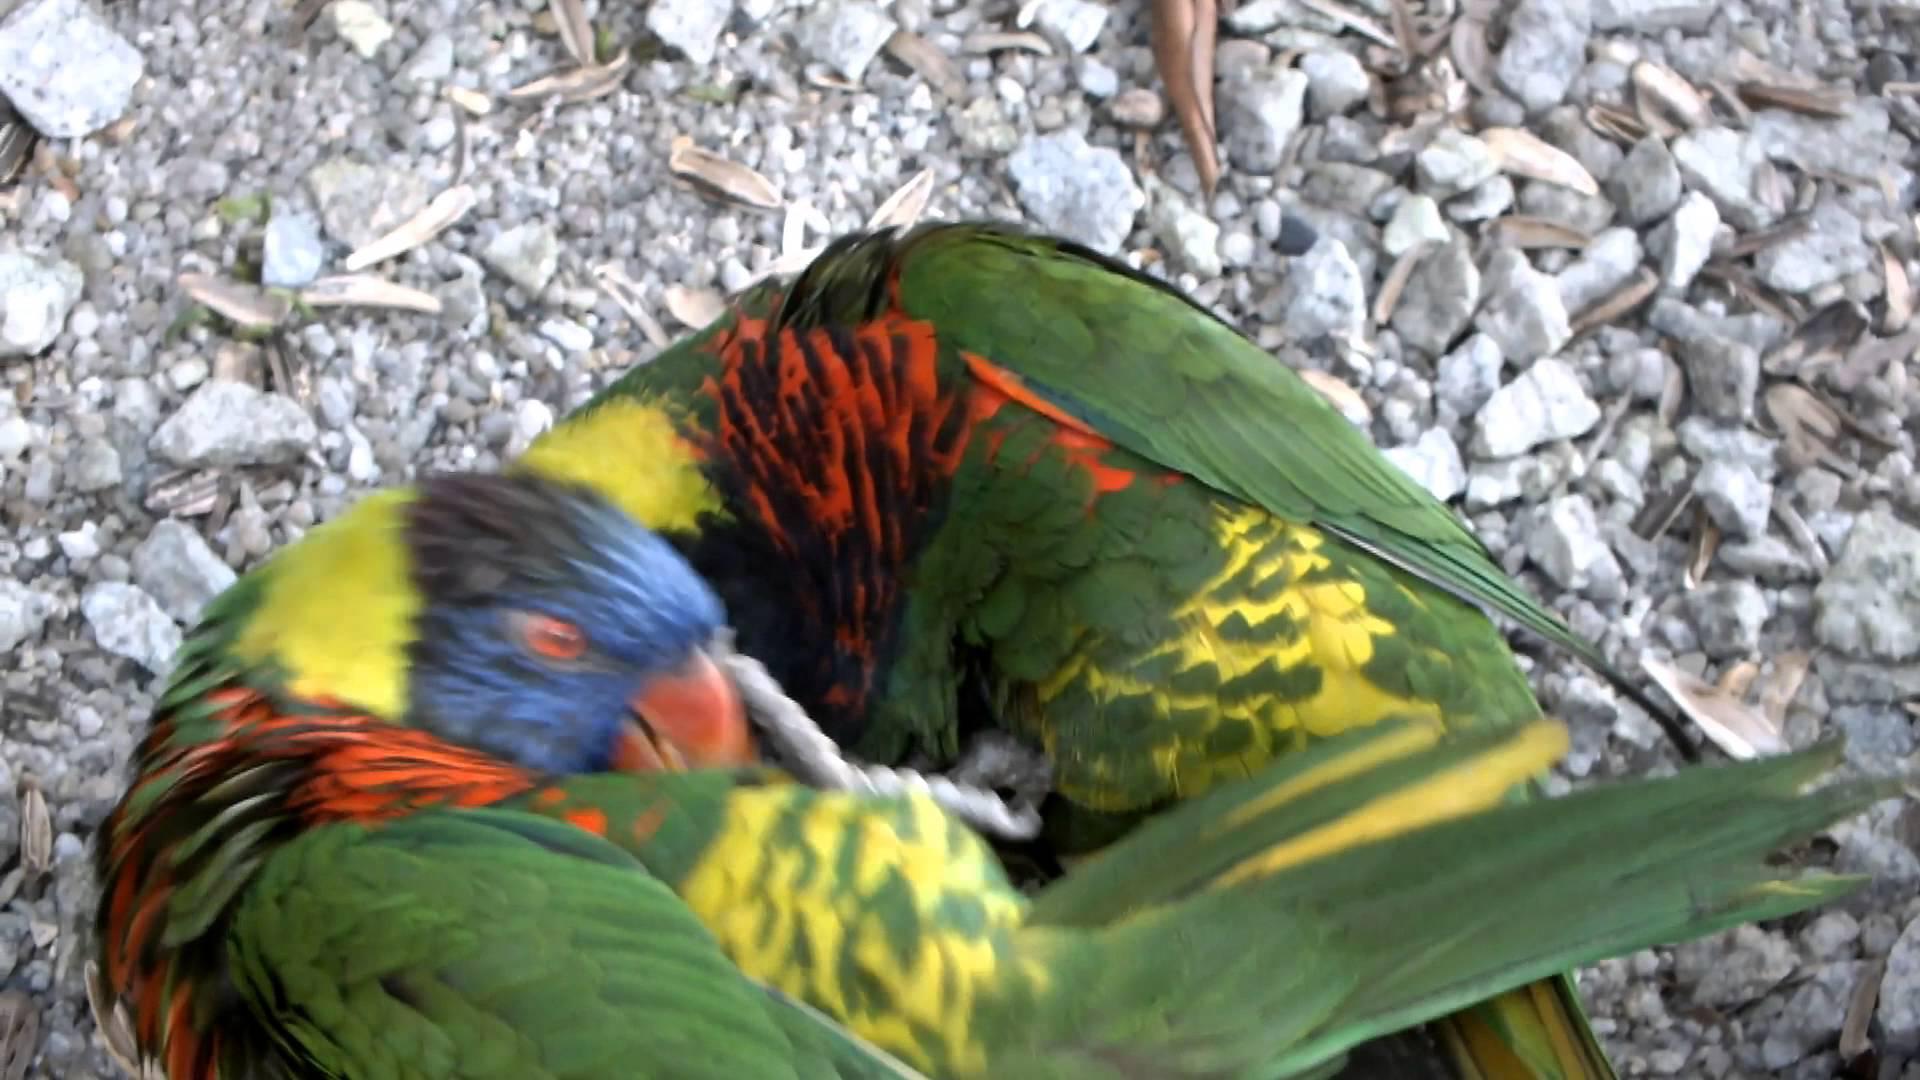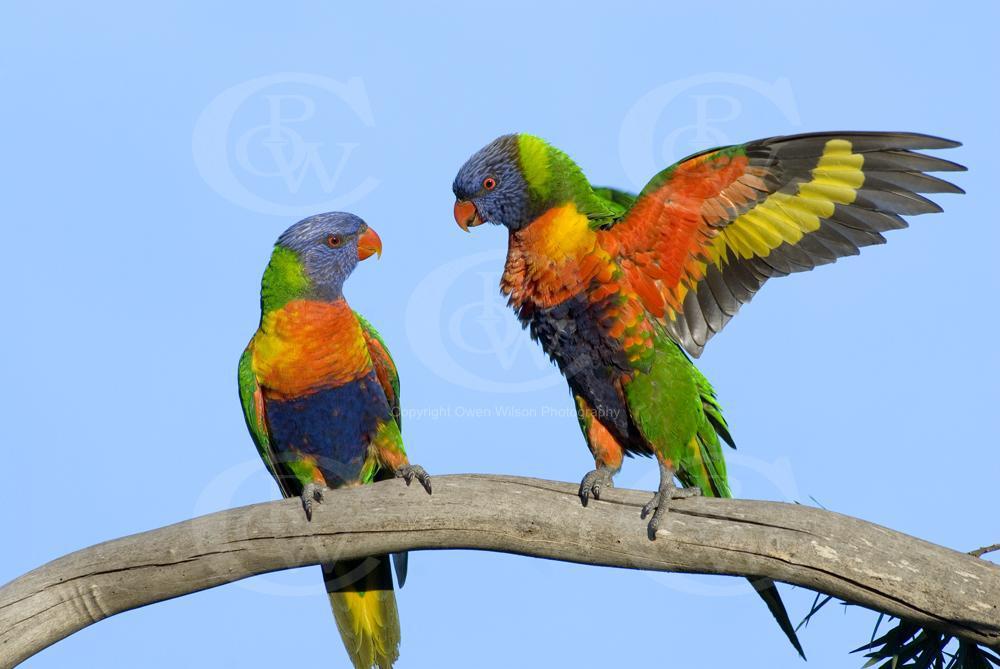The first image is the image on the left, the second image is the image on the right. Examine the images to the left and right. Is the description "There are no more than two parrots in the right image." accurate? Answer yes or no. Yes. The first image is the image on the left, the second image is the image on the right. Evaluate the accuracy of this statement regarding the images: "In at least one of the images there are four or more rainbow lorikeets gathered together.". Is it true? Answer yes or no. No. The first image is the image on the left, the second image is the image on the right. For the images displayed, is the sentence "There is at most four rainbow lorikeets." factually correct? Answer yes or no. Yes. The first image is the image on the left, the second image is the image on the right. Examine the images to the left and right. Is the description "There are no less than five colorful birds" accurate? Answer yes or no. No. 